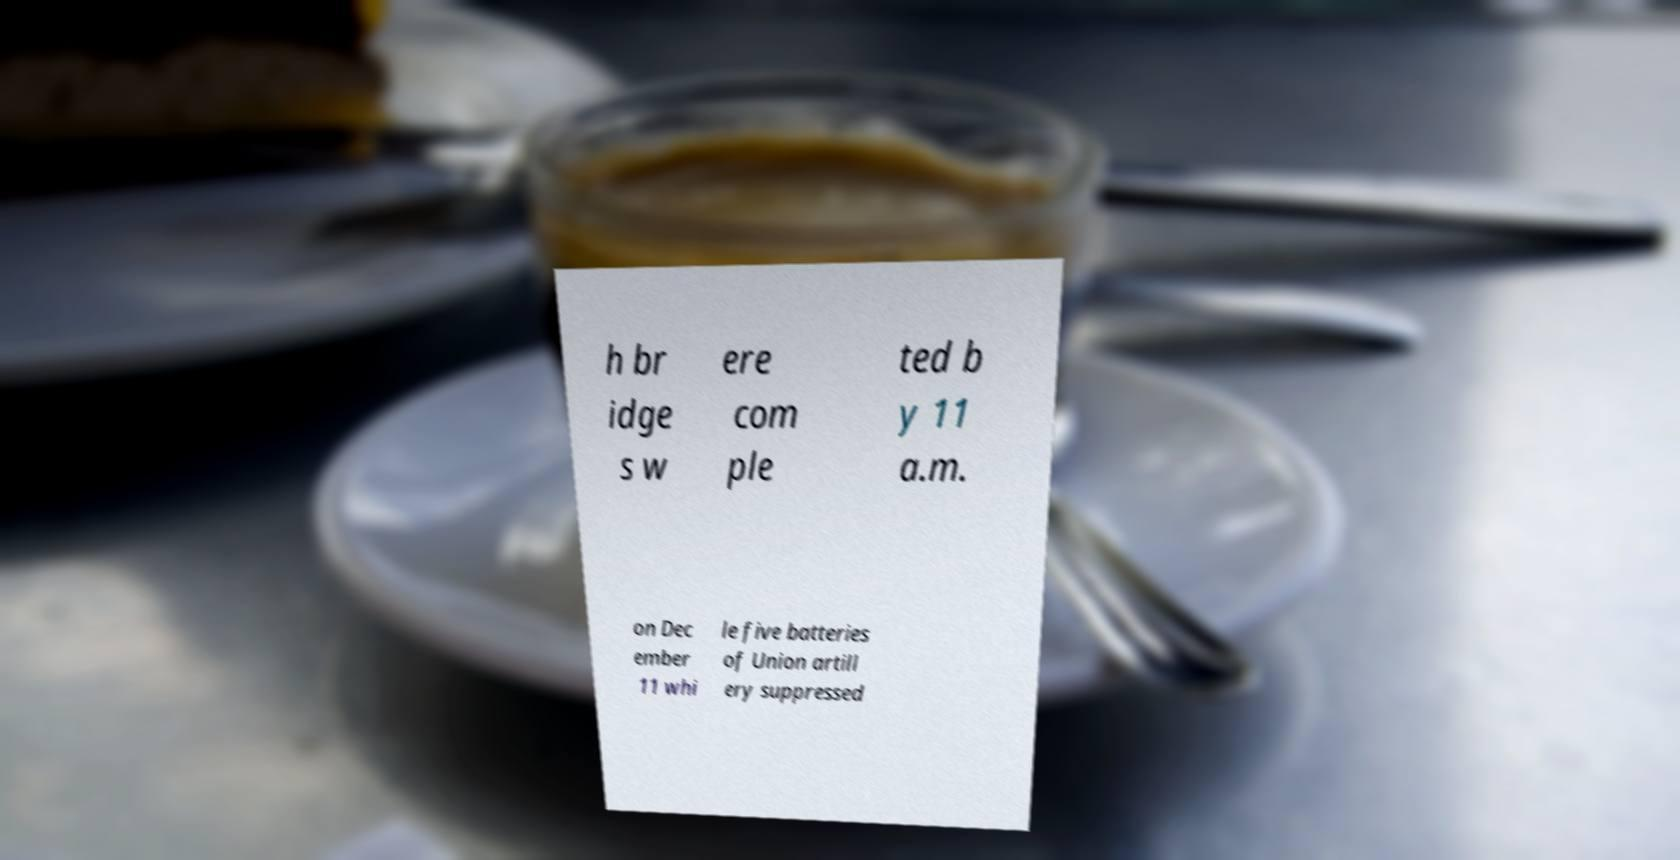Can you read and provide the text displayed in the image?This photo seems to have some interesting text. Can you extract and type it out for me? h br idge s w ere com ple ted b y 11 a.m. on Dec ember 11 whi le five batteries of Union artill ery suppressed 